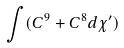<formula> <loc_0><loc_0><loc_500><loc_500>\int ( C ^ { 9 } + C ^ { 8 } d \chi ^ { \prime } )</formula> 